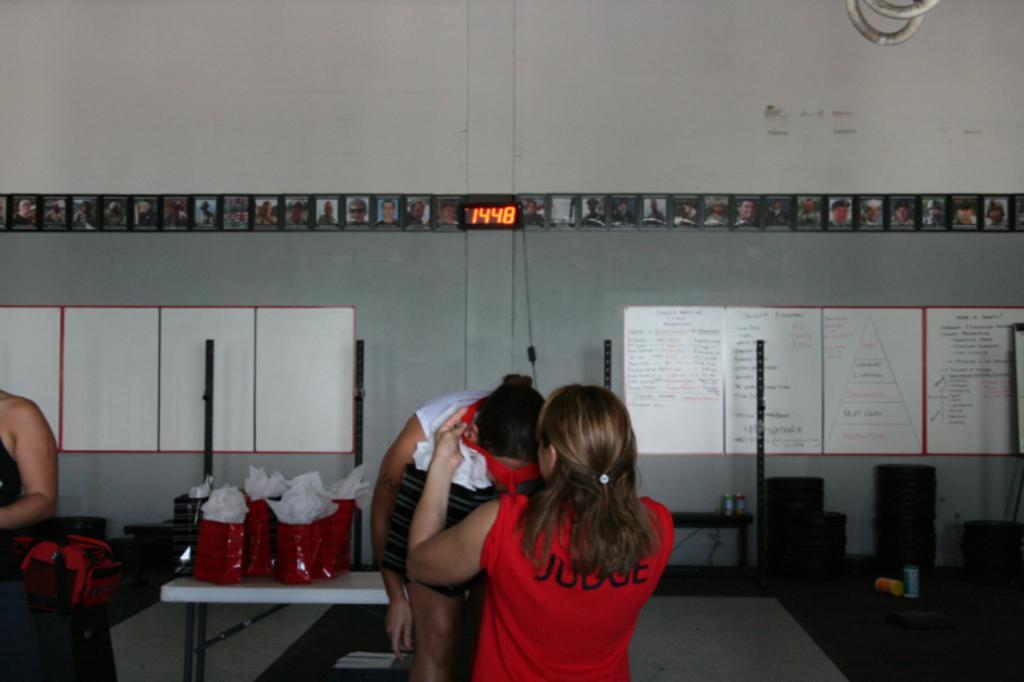Please provide a concise description of this image. In this picture in the front there are persons standing. In the center there is a table which is white in colour, on the table there are objects which are red and white in colour. In the background there is a wall, on the wall there are boards with some text written on it. In front of the wall there are objects which are black in colour and there are bottles on the floor. On the wall there are numbers displaying on the black colour board. 